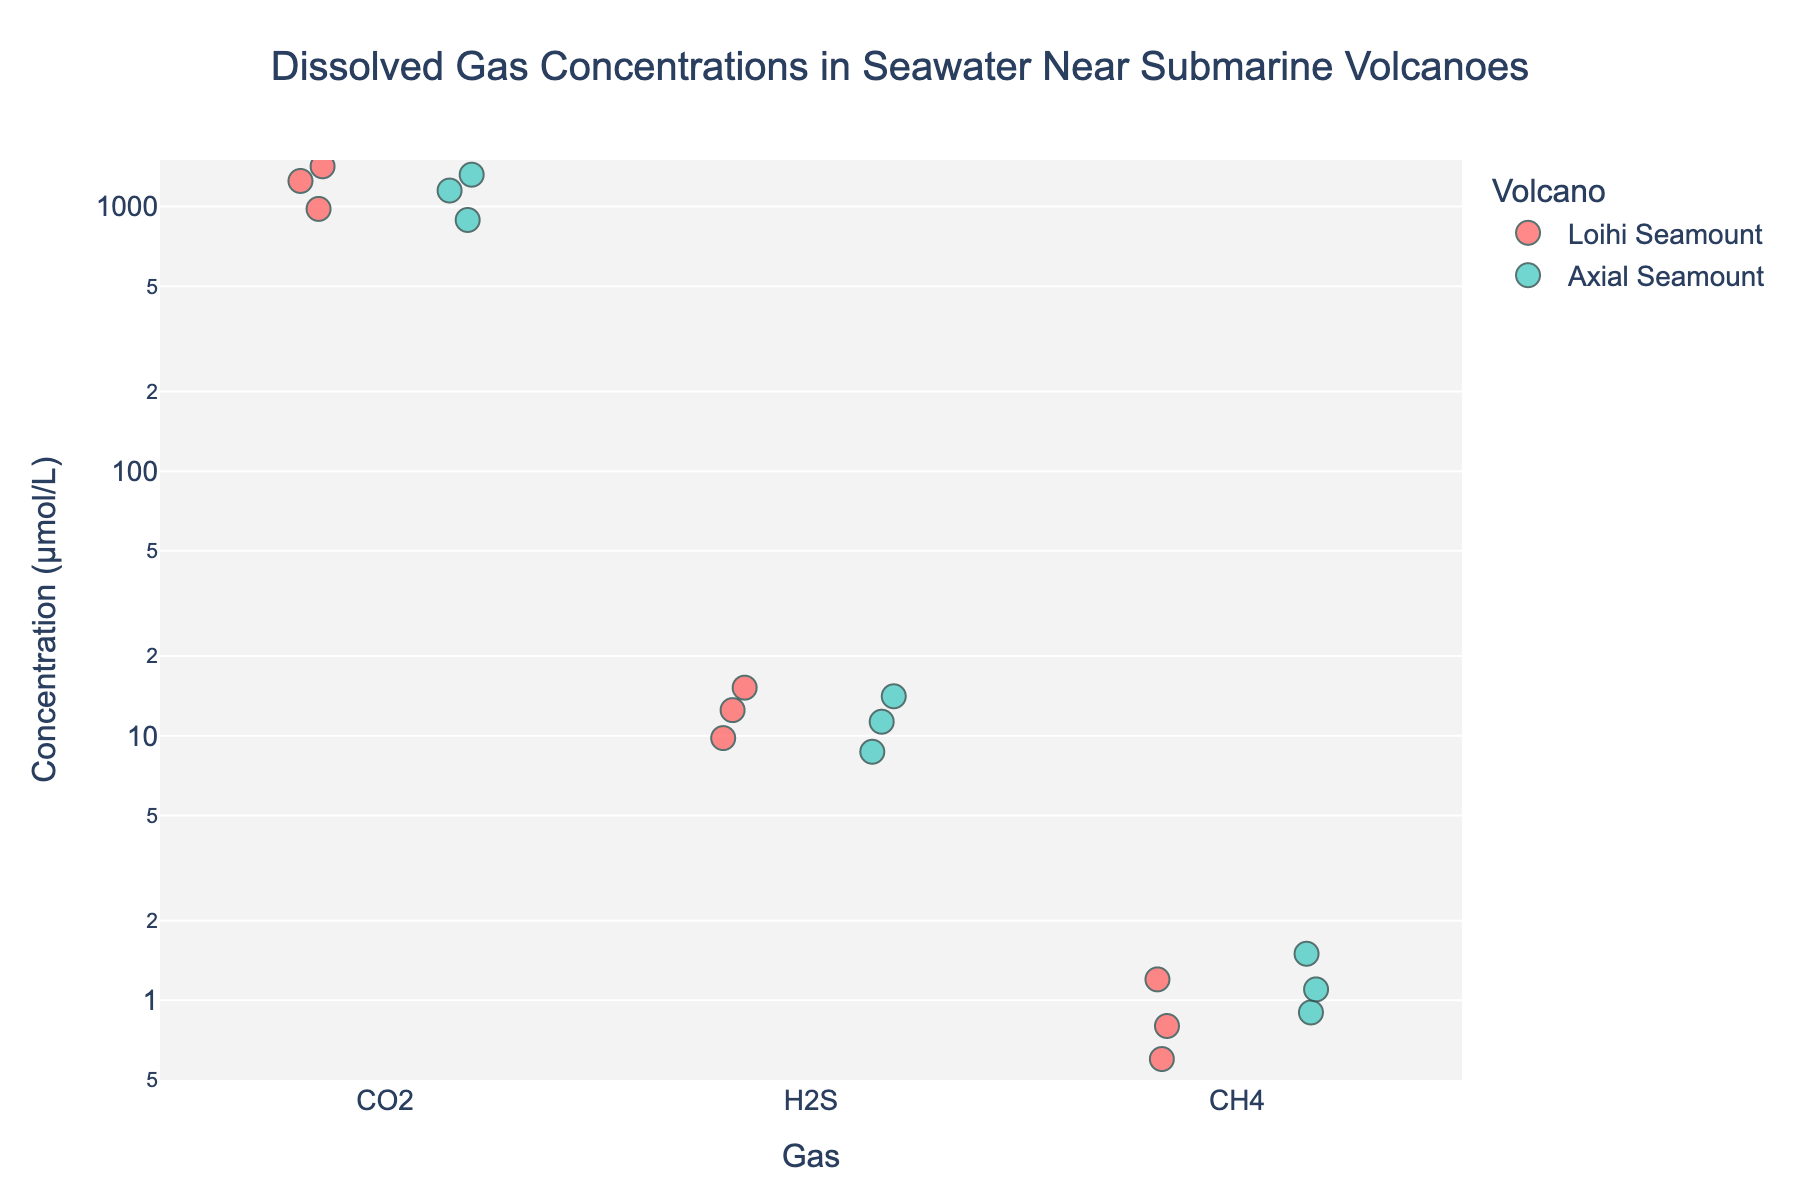What are the three types of dissolved gases measured in the seawater samples? The x-axis of the strip plot categorizes the dissolved gases, which are labeled as CO2, H2S, and CH4.
Answer: CO2, H2S, CH4 Which volcano shows higher concentrations of CO2? The data points for CO2 are distinctly colored by the volcano, with Loihi Seamount (red) and Axial Seamount (turquoise). The data points for Loihi Seamount show higher CO2 concentration values compared to Axial Seamount.
Answer: Loihi Seamount What is the range of H2S concentration values for Axial Seamount? Observing the H2S values for Axial Seamount (turquoise), the range can be identified as between 8.7 μmol/L and 14.1 μmol/L.
Answer: 8.7 - 14.1 μmol/L How do the concentrations of CH4 compare between Loihi and Axial Seamounts? Looking at the CH4 values, Loihi Seamount (red) ranges from 0.6 μmol/L to 1.2 μmol/L, while Axial Seamount (turquoise) ranges from 0.9 μmol/L to 1.5 μmol/L, indicating that Axial Seamount has slightly higher concentrations.
Answer: Axial Seamount has higher CH4 concentrations How many CO2 data points are there in total? By counting the data points in the strip plot under the CO2 category, we see there are 3 points for Loihi Seamount and 3 points for Axial Seamount, making a total of 6 data points.
Answer: 6 Which gas type shows the greatest variability in concentration? Observing the spread of data points (the vertical range) for each gas, CO2 shows the greatest variability ranging from about 890 μmol/L to 1420 μmol/L.
Answer: CO2 Are there any gas concentrations that are the same for both Loihi and Axial Seamount? Examining the overlapping or equal values for different gases between the two volcanoes, there are no identical concentration values observed for Loihi and Axial Seamount.
Answer: No What is the highest recorded concentration value among all the gases? Observing the y-axis values for all gases, the highest recorded concentration is for CO2 at Loihi Seamount, which is 1420 μmol/L.
Answer: 1420 μmol/L What's the difference in the highest concentration values of CO2 between Loihi Seamount and Axial Seamount? The highest concentration of CO2 for Loihi Seamount is 1420 μmol/L and for Axial Seamount is 1320 μmol/L. The difference is 1420 - 1320 = 100 μmol/L.
Answer: 100 μmol/L 